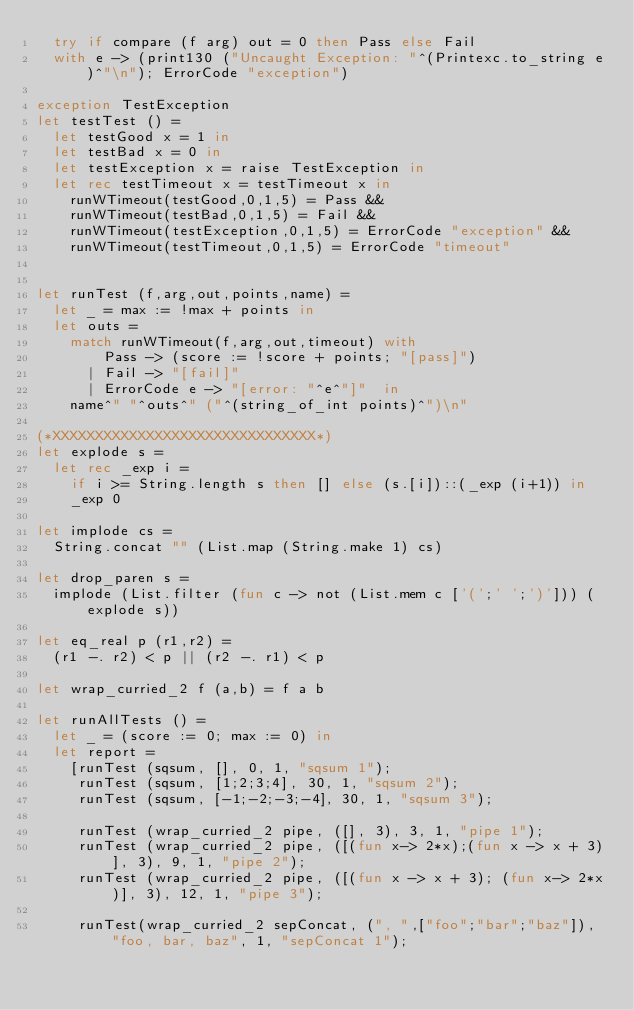Convert code to text. <code><loc_0><loc_0><loc_500><loc_500><_OCaml_>  try if compare (f arg) out = 0 then Pass else Fail
  with e -> (print130 ("Uncaught Exception: "^(Printexc.to_string e)^"\n"); ErrorCode "exception") 

exception TestException
let testTest () =
  let testGood x = 1 in
  let testBad x = 0 in 
  let testException x = raise TestException in
  let rec testTimeout x = testTimeout x in
    runWTimeout(testGood,0,1,5) = Pass &&  
    runWTimeout(testBad,0,1,5) = Fail &&  
    runWTimeout(testException,0,1,5) = ErrorCode "exception" && 
    runWTimeout(testTimeout,0,1,5) = ErrorCode "timeout"


let runTest (f,arg,out,points,name) =
  let _ = max := !max + points in
  let outs = 
    match runWTimeout(f,arg,out,timeout) with 
        Pass -> (score := !score + points; "[pass]")
      | Fail -> "[fail]"
      | ErrorCode e -> "[error: "^e^"]"  in
    name^" "^outs^" ("^(string_of_int points)^")\n"

(*XXXXXXXXXXXXXXXXXXXXXXXXXXXXXXX*)
let explode s = 
  let rec _exp i = 
    if i >= String.length s then [] else (s.[i])::(_exp (i+1)) in
    _exp 0

let implode cs = 
  String.concat "" (List.map (String.make 1) cs)

let drop_paren s = 
  implode (List.filter (fun c -> not (List.mem c ['(';' ';')'])) (explode s))

let eq_real p (r1,r2) = 
  (r1 -. r2) < p || (r2 -. r1) < p

let wrap_curried_2 f (a,b) = f a b

let runAllTests () =
  let _ = (score := 0; max := 0) in
  let report = 
    [runTest (sqsum, [], 0, 1, "sqsum 1");
     runTest (sqsum, [1;2;3;4], 30, 1, "sqsum 2");
     runTest (sqsum, [-1;-2;-3;-4], 30, 1, "sqsum 3");

     runTest (wrap_curried_2 pipe, ([], 3), 3, 1, "pipe 1");
     runTest (wrap_curried_2 pipe, ([(fun x-> 2*x);(fun x -> x + 3)], 3), 9, 1, "pipe 2");
     runTest (wrap_curried_2 pipe, ([(fun x -> x + 3); (fun x-> 2*x)], 3), 12, 1, "pipe 3");

     runTest(wrap_curried_2 sepConcat, (", ",["foo";"bar";"baz"]), "foo, bar, baz", 1, "sepConcat 1");</code> 